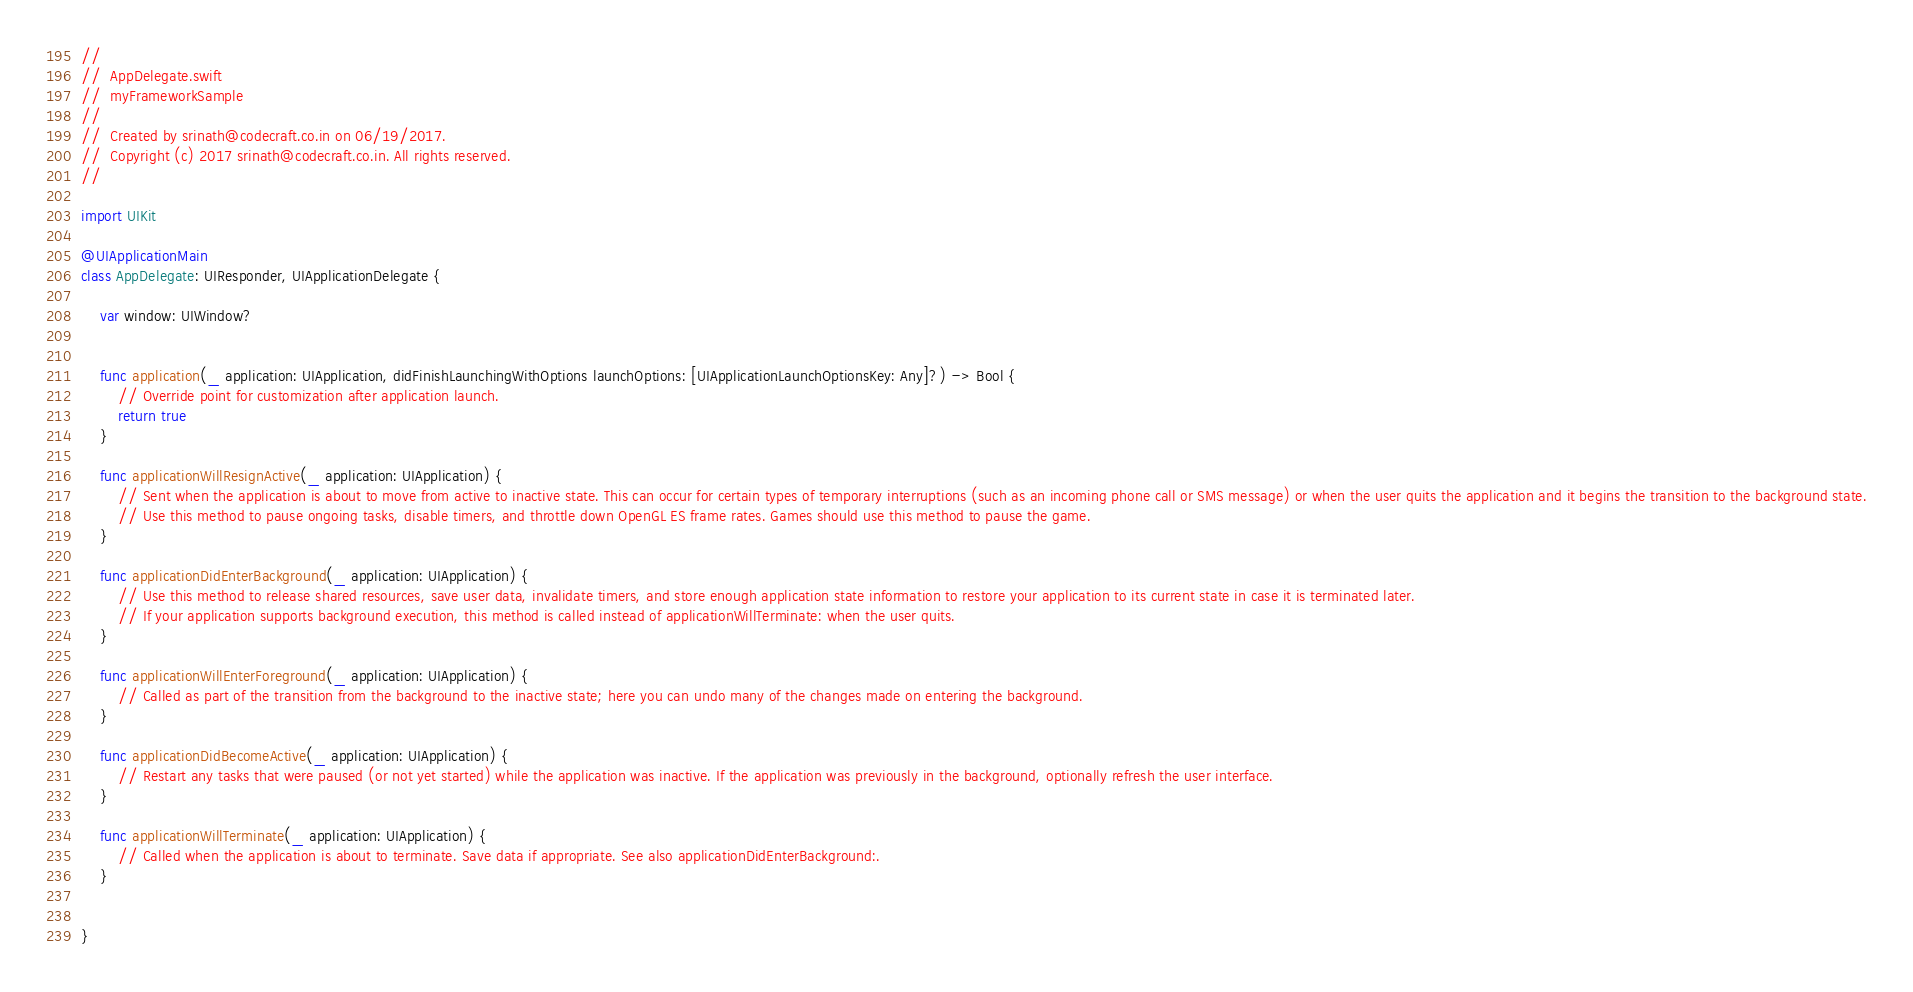<code> <loc_0><loc_0><loc_500><loc_500><_Swift_>//
//  AppDelegate.swift
//  myFrameworkSample
//
//  Created by srinath@codecraft.co.in on 06/19/2017.
//  Copyright (c) 2017 srinath@codecraft.co.in. All rights reserved.
//

import UIKit

@UIApplicationMain
class AppDelegate: UIResponder, UIApplicationDelegate {

    var window: UIWindow?


    func application(_ application: UIApplication, didFinishLaunchingWithOptions launchOptions: [UIApplicationLaunchOptionsKey: Any]?) -> Bool {
        // Override point for customization after application launch.
        return true
    }

    func applicationWillResignActive(_ application: UIApplication) {
        // Sent when the application is about to move from active to inactive state. This can occur for certain types of temporary interruptions (such as an incoming phone call or SMS message) or when the user quits the application and it begins the transition to the background state.
        // Use this method to pause ongoing tasks, disable timers, and throttle down OpenGL ES frame rates. Games should use this method to pause the game.
    }

    func applicationDidEnterBackground(_ application: UIApplication) {
        // Use this method to release shared resources, save user data, invalidate timers, and store enough application state information to restore your application to its current state in case it is terminated later.
        // If your application supports background execution, this method is called instead of applicationWillTerminate: when the user quits.
    }

    func applicationWillEnterForeground(_ application: UIApplication) {
        // Called as part of the transition from the background to the inactive state; here you can undo many of the changes made on entering the background.
    }

    func applicationDidBecomeActive(_ application: UIApplication) {
        // Restart any tasks that were paused (or not yet started) while the application was inactive. If the application was previously in the background, optionally refresh the user interface.
    }

    func applicationWillTerminate(_ application: UIApplication) {
        // Called when the application is about to terminate. Save data if appropriate. See also applicationDidEnterBackground:.
    }


}

</code> 